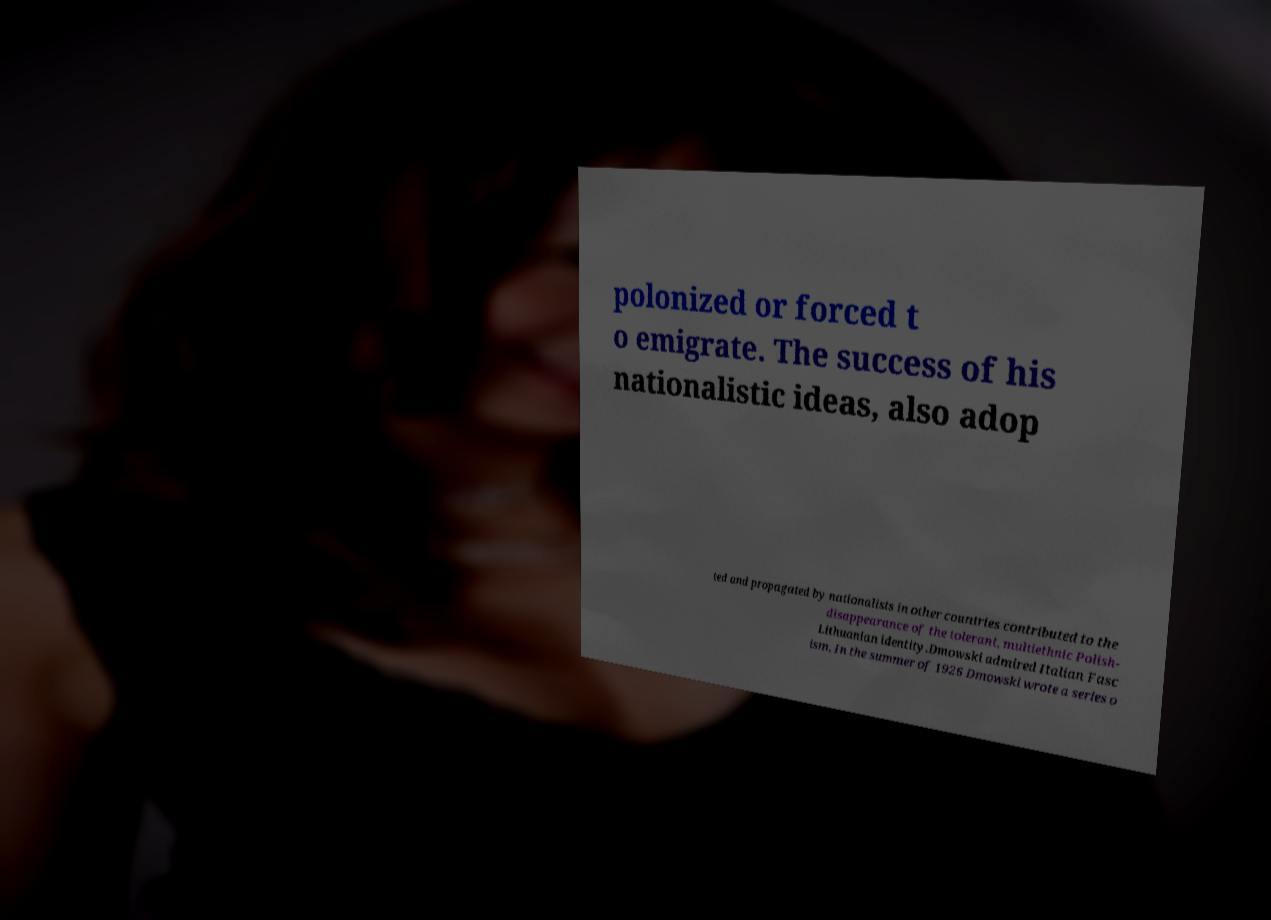Please identify and transcribe the text found in this image. polonized or forced t o emigrate. The success of his nationalistic ideas, also adop ted and propagated by nationalists in other countries contributed to the disappearance of the tolerant, multiethnic Polish- Lithuanian identity.Dmowski admired Italian Fasc ism. In the summer of 1926 Dmowski wrote a series o 